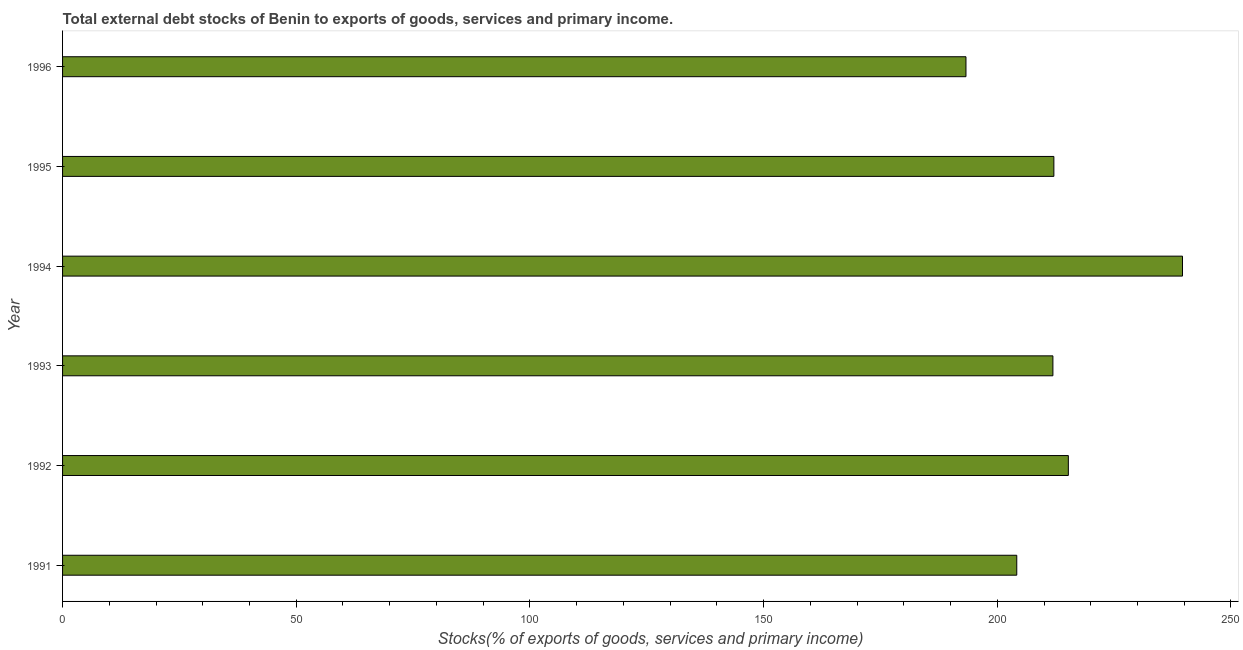Does the graph contain grids?
Keep it short and to the point. No. What is the title of the graph?
Your answer should be very brief. Total external debt stocks of Benin to exports of goods, services and primary income. What is the label or title of the X-axis?
Provide a short and direct response. Stocks(% of exports of goods, services and primary income). What is the label or title of the Y-axis?
Provide a short and direct response. Year. What is the external debt stocks in 1992?
Make the answer very short. 215.21. Across all years, what is the maximum external debt stocks?
Your answer should be compact. 239.63. Across all years, what is the minimum external debt stocks?
Offer a terse response. 193.3. In which year was the external debt stocks maximum?
Your answer should be very brief. 1994. What is the sum of the external debt stocks?
Offer a very short reply. 1276.33. What is the difference between the external debt stocks in 1992 and 1996?
Your answer should be very brief. 21.9. What is the average external debt stocks per year?
Make the answer very short. 212.72. What is the median external debt stocks?
Your response must be concise. 212.01. In how many years, is the external debt stocks greater than 90 %?
Offer a terse response. 6. What is the ratio of the external debt stocks in 1995 to that in 1996?
Your answer should be compact. 1.1. What is the difference between the highest and the second highest external debt stocks?
Make the answer very short. 24.43. Is the sum of the external debt stocks in 1991 and 1994 greater than the maximum external debt stocks across all years?
Offer a very short reply. Yes. What is the difference between the highest and the lowest external debt stocks?
Your answer should be compact. 46.33. How many bars are there?
Give a very brief answer. 6. How many years are there in the graph?
Your answer should be very brief. 6. Are the values on the major ticks of X-axis written in scientific E-notation?
Provide a succinct answer. No. What is the Stocks(% of exports of goods, services and primary income) in 1991?
Make the answer very short. 204.17. What is the Stocks(% of exports of goods, services and primary income) of 1992?
Keep it short and to the point. 215.21. What is the Stocks(% of exports of goods, services and primary income) of 1993?
Your response must be concise. 211.9. What is the Stocks(% of exports of goods, services and primary income) of 1994?
Give a very brief answer. 239.63. What is the Stocks(% of exports of goods, services and primary income) of 1995?
Provide a short and direct response. 212.11. What is the Stocks(% of exports of goods, services and primary income) in 1996?
Give a very brief answer. 193.3. What is the difference between the Stocks(% of exports of goods, services and primary income) in 1991 and 1992?
Give a very brief answer. -11.04. What is the difference between the Stocks(% of exports of goods, services and primary income) in 1991 and 1993?
Keep it short and to the point. -7.73. What is the difference between the Stocks(% of exports of goods, services and primary income) in 1991 and 1994?
Make the answer very short. -35.46. What is the difference between the Stocks(% of exports of goods, services and primary income) in 1991 and 1995?
Offer a very short reply. -7.94. What is the difference between the Stocks(% of exports of goods, services and primary income) in 1991 and 1996?
Give a very brief answer. 10.87. What is the difference between the Stocks(% of exports of goods, services and primary income) in 1992 and 1993?
Your answer should be very brief. 3.3. What is the difference between the Stocks(% of exports of goods, services and primary income) in 1992 and 1994?
Provide a short and direct response. -24.43. What is the difference between the Stocks(% of exports of goods, services and primary income) in 1992 and 1995?
Offer a very short reply. 3.1. What is the difference between the Stocks(% of exports of goods, services and primary income) in 1992 and 1996?
Offer a terse response. 21.9. What is the difference between the Stocks(% of exports of goods, services and primary income) in 1993 and 1994?
Offer a very short reply. -27.73. What is the difference between the Stocks(% of exports of goods, services and primary income) in 1993 and 1995?
Make the answer very short. -0.21. What is the difference between the Stocks(% of exports of goods, services and primary income) in 1993 and 1996?
Ensure brevity in your answer.  18.6. What is the difference between the Stocks(% of exports of goods, services and primary income) in 1994 and 1995?
Make the answer very short. 27.52. What is the difference between the Stocks(% of exports of goods, services and primary income) in 1994 and 1996?
Keep it short and to the point. 46.33. What is the difference between the Stocks(% of exports of goods, services and primary income) in 1995 and 1996?
Provide a short and direct response. 18.81. What is the ratio of the Stocks(% of exports of goods, services and primary income) in 1991 to that in 1992?
Offer a terse response. 0.95. What is the ratio of the Stocks(% of exports of goods, services and primary income) in 1991 to that in 1993?
Give a very brief answer. 0.96. What is the ratio of the Stocks(% of exports of goods, services and primary income) in 1991 to that in 1994?
Offer a terse response. 0.85. What is the ratio of the Stocks(% of exports of goods, services and primary income) in 1991 to that in 1995?
Provide a short and direct response. 0.96. What is the ratio of the Stocks(% of exports of goods, services and primary income) in 1991 to that in 1996?
Offer a terse response. 1.06. What is the ratio of the Stocks(% of exports of goods, services and primary income) in 1992 to that in 1994?
Your answer should be compact. 0.9. What is the ratio of the Stocks(% of exports of goods, services and primary income) in 1992 to that in 1996?
Your response must be concise. 1.11. What is the ratio of the Stocks(% of exports of goods, services and primary income) in 1993 to that in 1994?
Offer a terse response. 0.88. What is the ratio of the Stocks(% of exports of goods, services and primary income) in 1993 to that in 1996?
Your answer should be compact. 1.1. What is the ratio of the Stocks(% of exports of goods, services and primary income) in 1994 to that in 1995?
Keep it short and to the point. 1.13. What is the ratio of the Stocks(% of exports of goods, services and primary income) in 1994 to that in 1996?
Offer a terse response. 1.24. What is the ratio of the Stocks(% of exports of goods, services and primary income) in 1995 to that in 1996?
Ensure brevity in your answer.  1.1. 